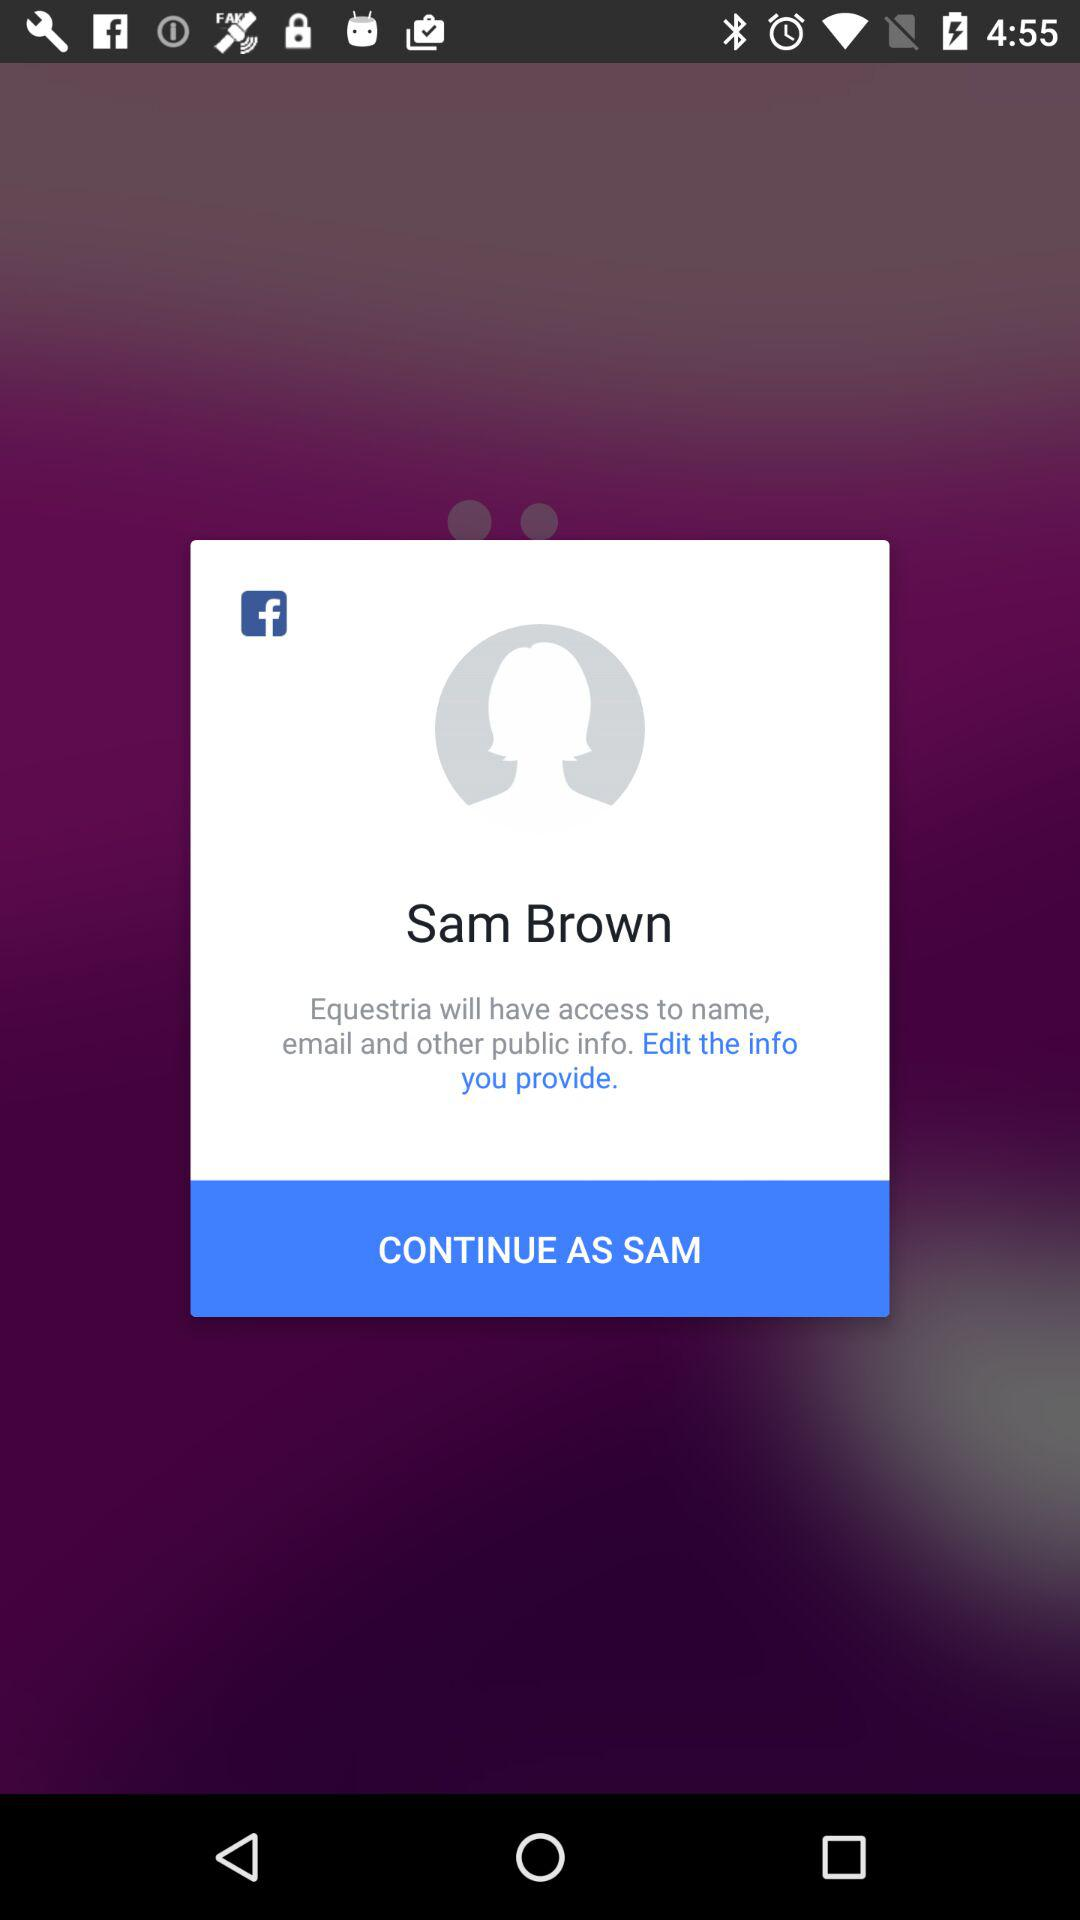What application is asking for permission? The application asking for permission is "Equestria". 